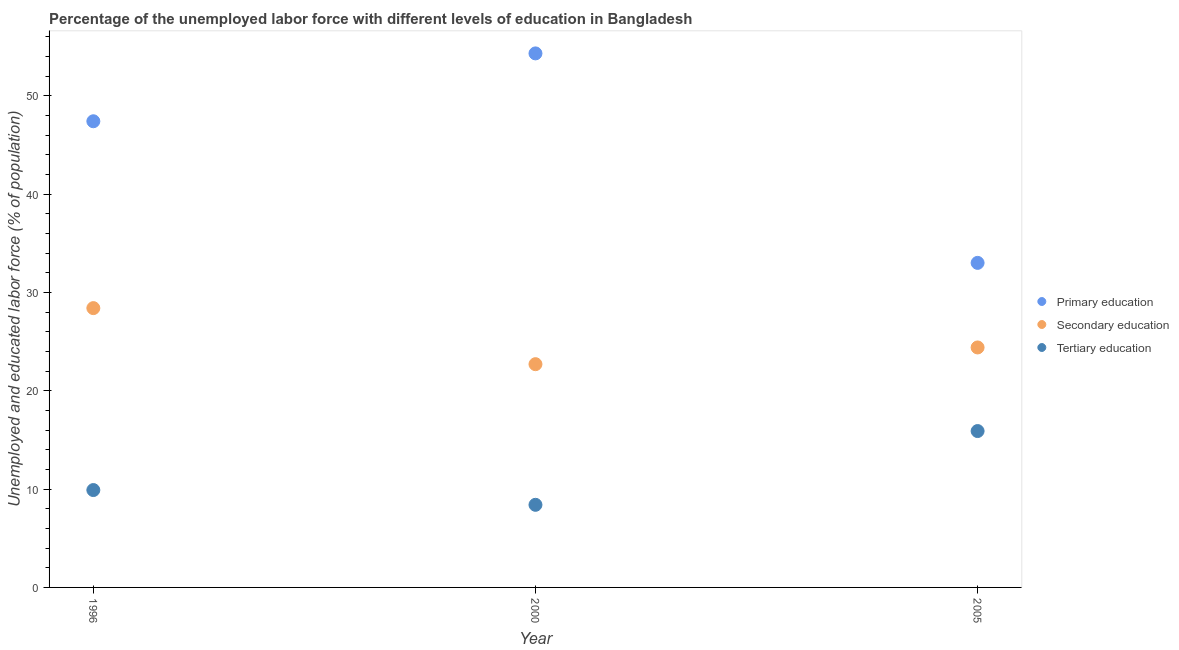What is the percentage of labor force who received secondary education in 2005?
Keep it short and to the point. 24.4. Across all years, what is the maximum percentage of labor force who received tertiary education?
Offer a terse response. 15.9. In which year was the percentage of labor force who received tertiary education minimum?
Your answer should be compact. 2000. What is the total percentage of labor force who received tertiary education in the graph?
Keep it short and to the point. 34.2. What is the difference between the percentage of labor force who received secondary education in 2000 and that in 2005?
Offer a very short reply. -1.7. What is the difference between the percentage of labor force who received primary education in 1996 and the percentage of labor force who received tertiary education in 2005?
Your answer should be very brief. 31.5. What is the average percentage of labor force who received secondary education per year?
Ensure brevity in your answer.  25.17. In the year 1996, what is the difference between the percentage of labor force who received primary education and percentage of labor force who received tertiary education?
Provide a succinct answer. 37.5. In how many years, is the percentage of labor force who received tertiary education greater than 38 %?
Offer a terse response. 0. What is the ratio of the percentage of labor force who received primary education in 1996 to that in 2005?
Ensure brevity in your answer.  1.44. Is the percentage of labor force who received tertiary education in 1996 less than that in 2000?
Make the answer very short. No. Is the difference between the percentage of labor force who received primary education in 2000 and 2005 greater than the difference between the percentage of labor force who received tertiary education in 2000 and 2005?
Make the answer very short. Yes. What is the difference between the highest and the second highest percentage of labor force who received primary education?
Keep it short and to the point. 6.9. What is the difference between the highest and the lowest percentage of labor force who received tertiary education?
Make the answer very short. 7.5. In how many years, is the percentage of labor force who received secondary education greater than the average percentage of labor force who received secondary education taken over all years?
Offer a very short reply. 1. Is the sum of the percentage of labor force who received tertiary education in 1996 and 2005 greater than the maximum percentage of labor force who received primary education across all years?
Provide a short and direct response. No. Is it the case that in every year, the sum of the percentage of labor force who received primary education and percentage of labor force who received secondary education is greater than the percentage of labor force who received tertiary education?
Your response must be concise. Yes. Is the percentage of labor force who received primary education strictly less than the percentage of labor force who received secondary education over the years?
Give a very brief answer. No. How many dotlines are there?
Make the answer very short. 3. How many years are there in the graph?
Your answer should be compact. 3. What is the difference between two consecutive major ticks on the Y-axis?
Offer a very short reply. 10. Are the values on the major ticks of Y-axis written in scientific E-notation?
Ensure brevity in your answer.  No. Does the graph contain any zero values?
Your response must be concise. No. What is the title of the graph?
Your answer should be very brief. Percentage of the unemployed labor force with different levels of education in Bangladesh. Does "Domestic" appear as one of the legend labels in the graph?
Ensure brevity in your answer.  No. What is the label or title of the Y-axis?
Ensure brevity in your answer.  Unemployed and educated labor force (% of population). What is the Unemployed and educated labor force (% of population) in Primary education in 1996?
Provide a short and direct response. 47.4. What is the Unemployed and educated labor force (% of population) of Secondary education in 1996?
Keep it short and to the point. 28.4. What is the Unemployed and educated labor force (% of population) of Tertiary education in 1996?
Give a very brief answer. 9.9. What is the Unemployed and educated labor force (% of population) of Primary education in 2000?
Make the answer very short. 54.3. What is the Unemployed and educated labor force (% of population) of Secondary education in 2000?
Offer a very short reply. 22.7. What is the Unemployed and educated labor force (% of population) in Tertiary education in 2000?
Provide a succinct answer. 8.4. What is the Unemployed and educated labor force (% of population) of Secondary education in 2005?
Your answer should be compact. 24.4. What is the Unemployed and educated labor force (% of population) of Tertiary education in 2005?
Your response must be concise. 15.9. Across all years, what is the maximum Unemployed and educated labor force (% of population) in Primary education?
Your answer should be very brief. 54.3. Across all years, what is the maximum Unemployed and educated labor force (% of population) in Secondary education?
Your answer should be very brief. 28.4. Across all years, what is the maximum Unemployed and educated labor force (% of population) of Tertiary education?
Keep it short and to the point. 15.9. Across all years, what is the minimum Unemployed and educated labor force (% of population) of Primary education?
Make the answer very short. 33. Across all years, what is the minimum Unemployed and educated labor force (% of population) of Secondary education?
Your answer should be very brief. 22.7. Across all years, what is the minimum Unemployed and educated labor force (% of population) in Tertiary education?
Ensure brevity in your answer.  8.4. What is the total Unemployed and educated labor force (% of population) in Primary education in the graph?
Offer a very short reply. 134.7. What is the total Unemployed and educated labor force (% of population) in Secondary education in the graph?
Offer a terse response. 75.5. What is the total Unemployed and educated labor force (% of population) of Tertiary education in the graph?
Your answer should be very brief. 34.2. What is the difference between the Unemployed and educated labor force (% of population) of Primary education in 1996 and that in 2005?
Ensure brevity in your answer.  14.4. What is the difference between the Unemployed and educated labor force (% of population) in Primary education in 2000 and that in 2005?
Provide a succinct answer. 21.3. What is the difference between the Unemployed and educated labor force (% of population) in Secondary education in 2000 and that in 2005?
Your response must be concise. -1.7. What is the difference between the Unemployed and educated labor force (% of population) of Tertiary education in 2000 and that in 2005?
Offer a very short reply. -7.5. What is the difference between the Unemployed and educated labor force (% of population) in Primary education in 1996 and the Unemployed and educated labor force (% of population) in Secondary education in 2000?
Your response must be concise. 24.7. What is the difference between the Unemployed and educated labor force (% of population) in Primary education in 1996 and the Unemployed and educated labor force (% of population) in Tertiary education in 2000?
Offer a terse response. 39. What is the difference between the Unemployed and educated labor force (% of population) in Secondary education in 1996 and the Unemployed and educated labor force (% of population) in Tertiary education in 2000?
Your answer should be compact. 20. What is the difference between the Unemployed and educated labor force (% of population) of Primary education in 1996 and the Unemployed and educated labor force (% of population) of Secondary education in 2005?
Give a very brief answer. 23. What is the difference between the Unemployed and educated labor force (% of population) of Primary education in 1996 and the Unemployed and educated labor force (% of population) of Tertiary education in 2005?
Your answer should be compact. 31.5. What is the difference between the Unemployed and educated labor force (% of population) in Secondary education in 1996 and the Unemployed and educated labor force (% of population) in Tertiary education in 2005?
Provide a succinct answer. 12.5. What is the difference between the Unemployed and educated labor force (% of population) of Primary education in 2000 and the Unemployed and educated labor force (% of population) of Secondary education in 2005?
Make the answer very short. 29.9. What is the difference between the Unemployed and educated labor force (% of population) in Primary education in 2000 and the Unemployed and educated labor force (% of population) in Tertiary education in 2005?
Provide a short and direct response. 38.4. What is the difference between the Unemployed and educated labor force (% of population) of Secondary education in 2000 and the Unemployed and educated labor force (% of population) of Tertiary education in 2005?
Your response must be concise. 6.8. What is the average Unemployed and educated labor force (% of population) in Primary education per year?
Your response must be concise. 44.9. What is the average Unemployed and educated labor force (% of population) in Secondary education per year?
Your answer should be very brief. 25.17. In the year 1996, what is the difference between the Unemployed and educated labor force (% of population) of Primary education and Unemployed and educated labor force (% of population) of Secondary education?
Ensure brevity in your answer.  19. In the year 1996, what is the difference between the Unemployed and educated labor force (% of population) of Primary education and Unemployed and educated labor force (% of population) of Tertiary education?
Keep it short and to the point. 37.5. In the year 1996, what is the difference between the Unemployed and educated labor force (% of population) in Secondary education and Unemployed and educated labor force (% of population) in Tertiary education?
Provide a short and direct response. 18.5. In the year 2000, what is the difference between the Unemployed and educated labor force (% of population) of Primary education and Unemployed and educated labor force (% of population) of Secondary education?
Offer a terse response. 31.6. In the year 2000, what is the difference between the Unemployed and educated labor force (% of population) of Primary education and Unemployed and educated labor force (% of population) of Tertiary education?
Your response must be concise. 45.9. In the year 2005, what is the difference between the Unemployed and educated labor force (% of population) of Primary education and Unemployed and educated labor force (% of population) of Tertiary education?
Your response must be concise. 17.1. In the year 2005, what is the difference between the Unemployed and educated labor force (% of population) in Secondary education and Unemployed and educated labor force (% of population) in Tertiary education?
Offer a terse response. 8.5. What is the ratio of the Unemployed and educated labor force (% of population) in Primary education in 1996 to that in 2000?
Ensure brevity in your answer.  0.87. What is the ratio of the Unemployed and educated labor force (% of population) in Secondary education in 1996 to that in 2000?
Give a very brief answer. 1.25. What is the ratio of the Unemployed and educated labor force (% of population) of Tertiary education in 1996 to that in 2000?
Give a very brief answer. 1.18. What is the ratio of the Unemployed and educated labor force (% of population) in Primary education in 1996 to that in 2005?
Your answer should be very brief. 1.44. What is the ratio of the Unemployed and educated labor force (% of population) in Secondary education in 1996 to that in 2005?
Your response must be concise. 1.16. What is the ratio of the Unemployed and educated labor force (% of population) in Tertiary education in 1996 to that in 2005?
Offer a terse response. 0.62. What is the ratio of the Unemployed and educated labor force (% of population) in Primary education in 2000 to that in 2005?
Offer a very short reply. 1.65. What is the ratio of the Unemployed and educated labor force (% of population) of Secondary education in 2000 to that in 2005?
Your response must be concise. 0.93. What is the ratio of the Unemployed and educated labor force (% of population) of Tertiary education in 2000 to that in 2005?
Your answer should be very brief. 0.53. What is the difference between the highest and the second highest Unemployed and educated labor force (% of population) of Primary education?
Provide a succinct answer. 6.9. What is the difference between the highest and the second highest Unemployed and educated labor force (% of population) in Tertiary education?
Offer a very short reply. 6. What is the difference between the highest and the lowest Unemployed and educated labor force (% of population) in Primary education?
Provide a short and direct response. 21.3. What is the difference between the highest and the lowest Unemployed and educated labor force (% of population) of Secondary education?
Your response must be concise. 5.7. What is the difference between the highest and the lowest Unemployed and educated labor force (% of population) of Tertiary education?
Make the answer very short. 7.5. 